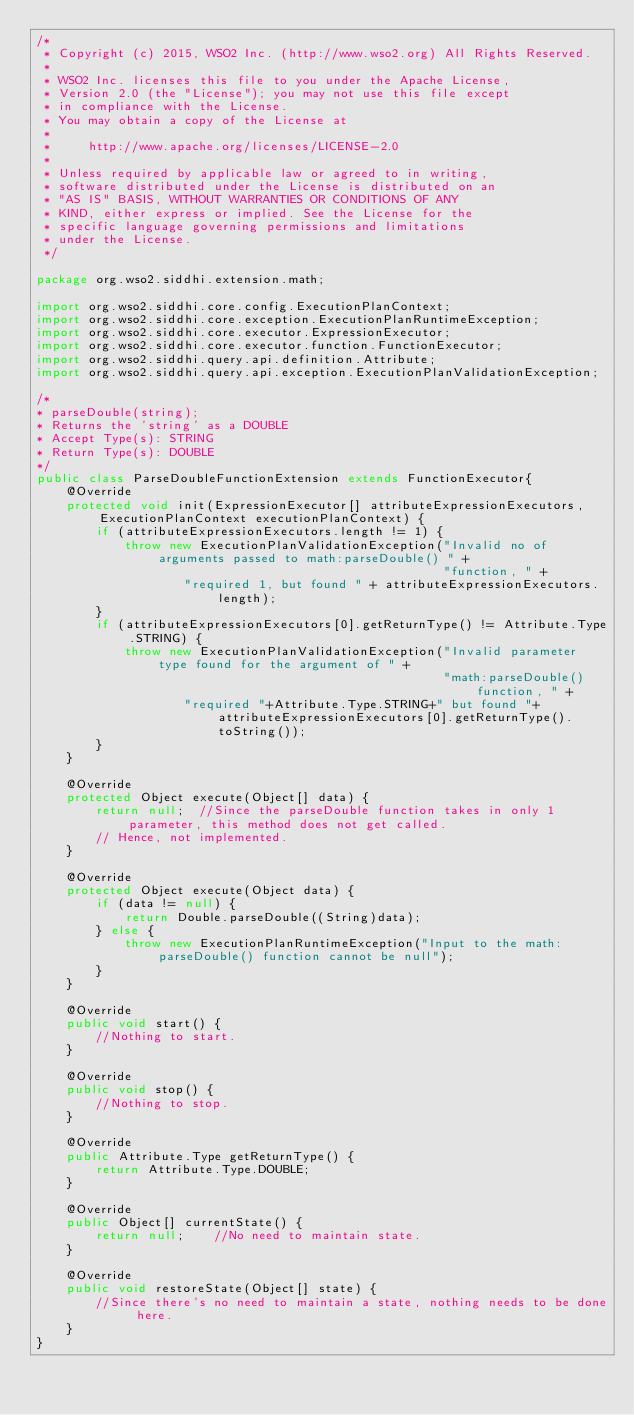Convert code to text. <code><loc_0><loc_0><loc_500><loc_500><_Java_>/*
 * Copyright (c) 2015, WSO2 Inc. (http://www.wso2.org) All Rights Reserved.
 *
 * WSO2 Inc. licenses this file to you under the Apache License,
 * Version 2.0 (the "License"); you may not use this file except
 * in compliance with the License.
 * You may obtain a copy of the License at
 *
 *     http://www.apache.org/licenses/LICENSE-2.0
 *
 * Unless required by applicable law or agreed to in writing,
 * software distributed under the License is distributed on an
 * "AS IS" BASIS, WITHOUT WARRANTIES OR CONDITIONS OF ANY
 * KIND, either express or implied. See the License for the
 * specific language governing permissions and limitations
 * under the License.
 */

package org.wso2.siddhi.extension.math;

import org.wso2.siddhi.core.config.ExecutionPlanContext;
import org.wso2.siddhi.core.exception.ExecutionPlanRuntimeException;
import org.wso2.siddhi.core.executor.ExpressionExecutor;
import org.wso2.siddhi.core.executor.function.FunctionExecutor;
import org.wso2.siddhi.query.api.definition.Attribute;
import org.wso2.siddhi.query.api.exception.ExecutionPlanValidationException;

/*
* parseDouble(string);
* Returns the 'string' as a DOUBLE
* Accept Type(s): STRING
* Return Type(s): DOUBLE
*/
public class ParseDoubleFunctionExtension extends FunctionExecutor{
    @Override
    protected void init(ExpressionExecutor[] attributeExpressionExecutors, ExecutionPlanContext executionPlanContext) {
        if (attributeExpressionExecutors.length != 1) {
            throw new ExecutionPlanValidationException("Invalid no of arguments passed to math:parseDouble() " +
                                                       "function, " +
                    "required 1, but found " + attributeExpressionExecutors.length);
        }
        if (attributeExpressionExecutors[0].getReturnType() != Attribute.Type.STRING) {
            throw new ExecutionPlanValidationException("Invalid parameter type found for the argument of " +
                                                       "math:parseDouble() function, " +
                    "required "+Attribute.Type.STRING+" but found "+attributeExpressionExecutors[0].getReturnType().toString());
        }
    }

    @Override
    protected Object execute(Object[] data) {
        return null;  //Since the parseDouble function takes in only 1 parameter, this method does not get called.
        // Hence, not implemented.
    }

    @Override
    protected Object execute(Object data) {
        if (data != null) {
            return Double.parseDouble((String)data);
        } else {
            throw new ExecutionPlanRuntimeException("Input to the math:parseDouble() function cannot be null");
        }
    }

    @Override
    public void start() {
        //Nothing to start.
    }

    @Override
    public void stop() {
        //Nothing to stop.
    }

    @Override
    public Attribute.Type getReturnType() {
        return Attribute.Type.DOUBLE;
    }

    @Override
    public Object[] currentState() {
        return null;    //No need to maintain state.
    }

    @Override
    public void restoreState(Object[] state) {
        //Since there's no need to maintain a state, nothing needs to be done here.
    }
}
</code> 